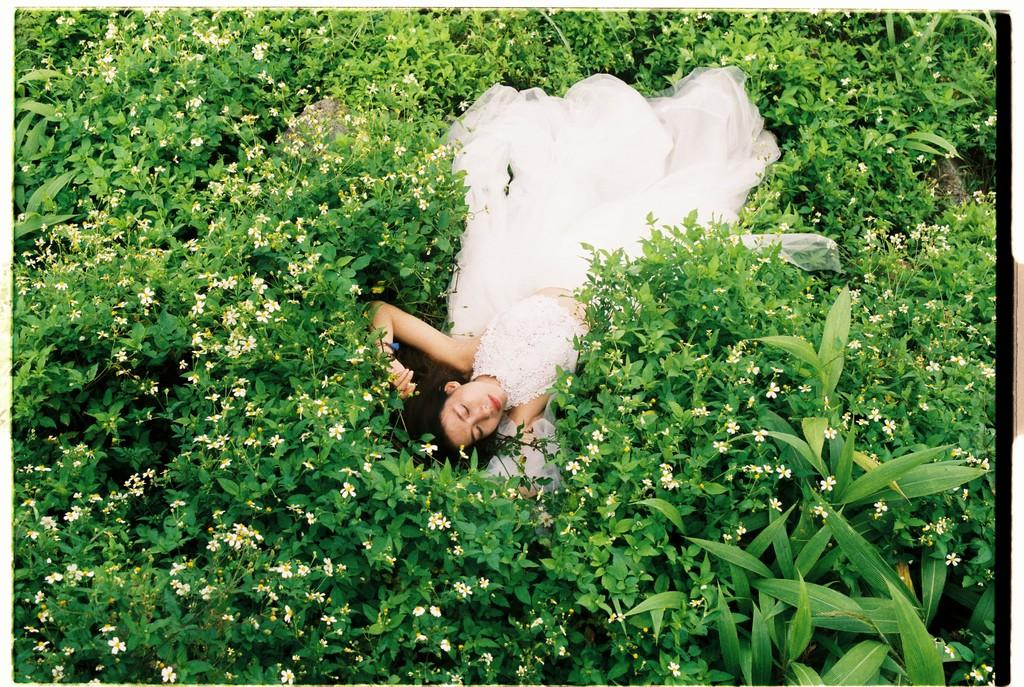What is the main subject of the image? There is a woman lying on the grass in the center of the image. What is the woman wearing? The woman is wearing a white frock. What type of natural environment is visible in the image? There is grass visible in the background of the image. What other natural elements can be seen in the image? There are flowers in the background of the image. What type of roof can be seen in the image? There is no roof present in the image; it features a woman lying on the grass in a natural setting. What town is visible in the background of the image? There is no town visible in the image; it is set in a natural environment with grass and flowers. 